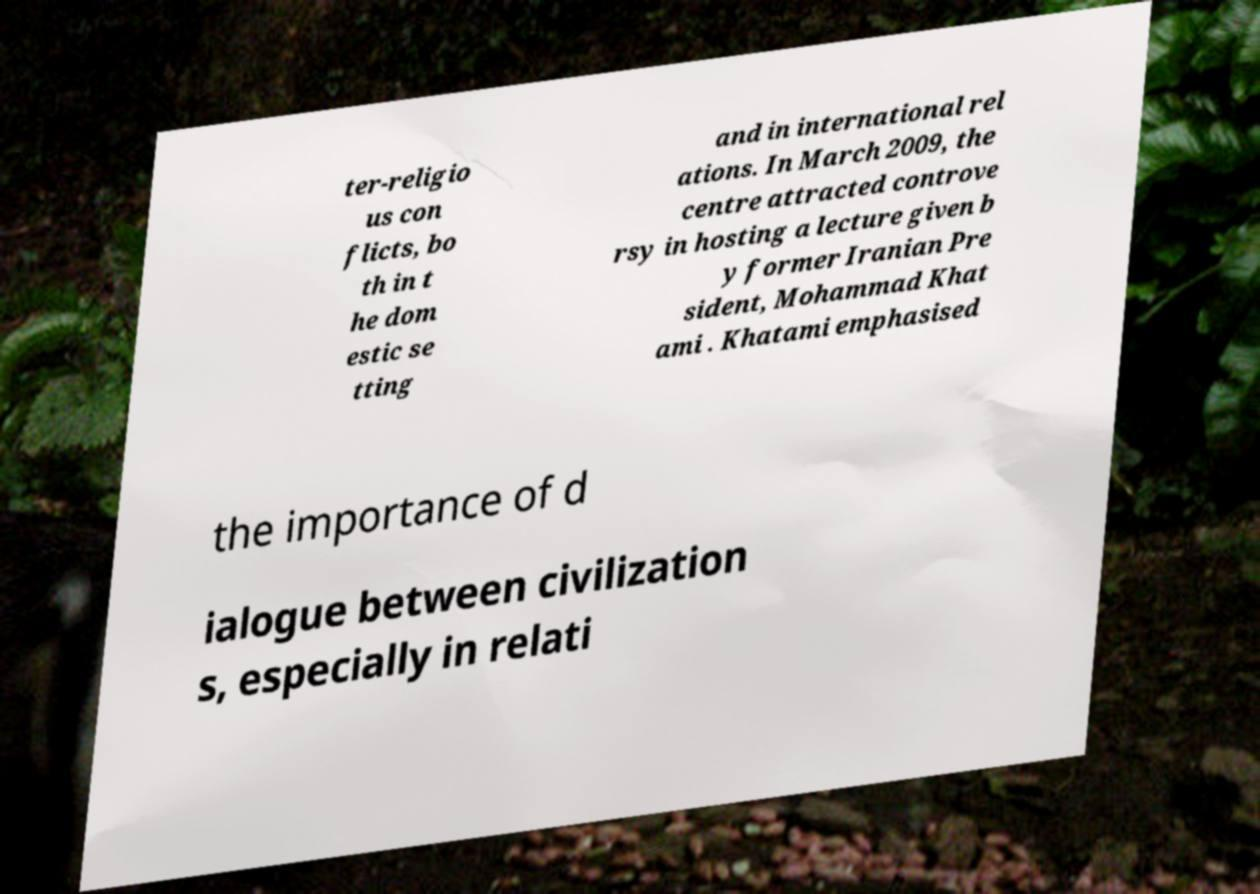What messages or text are displayed in this image? I need them in a readable, typed format. ter-religio us con flicts, bo th in t he dom estic se tting and in international rel ations. In March 2009, the centre attracted controve rsy in hosting a lecture given b y former Iranian Pre sident, Mohammad Khat ami . Khatami emphasised the importance of d ialogue between civilization s, especially in relati 